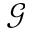<formula> <loc_0><loc_0><loc_500><loc_500>\mathcal { G }</formula> 